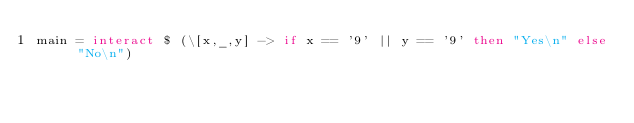<code> <loc_0><loc_0><loc_500><loc_500><_Haskell_>main = interact $ (\[x,_,y] -> if x == '9' || y == '9' then "Yes\n" else "No\n")
</code> 